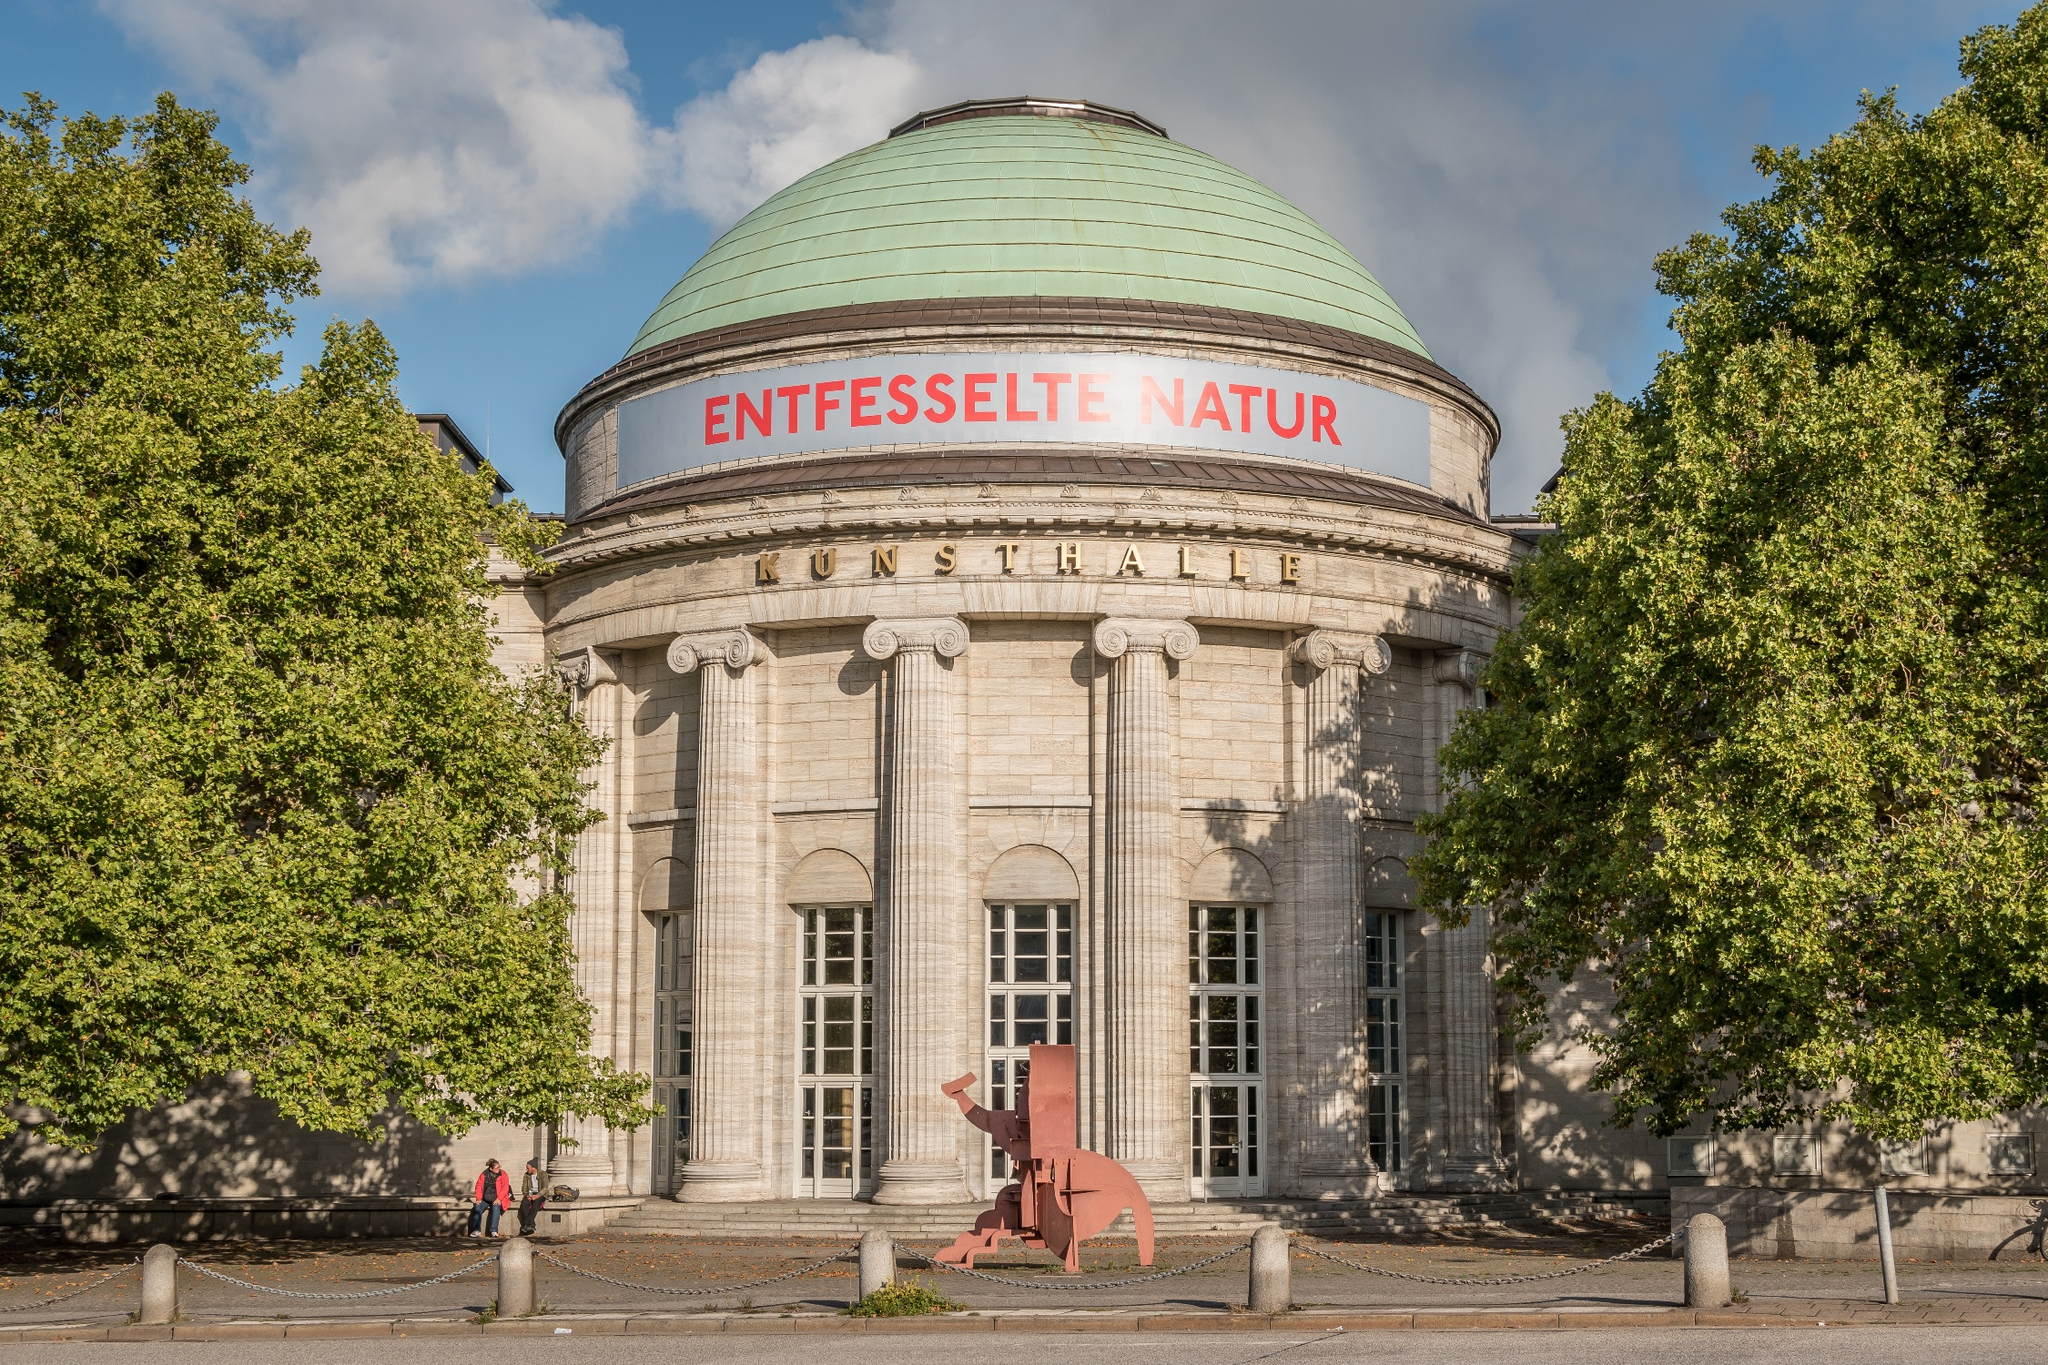What is this photo about'? The image captures the magnificent Kunsthalle Hamburg, a renowned art museum located in Hamburg, Germany. This architectural gem is an example of neoclassical design, characterized by a grand dome with a green patina and supported by elegant white columns. Nestled among vibrant trees, the museum offers a harmonious blend of nature and urban splendor. A striking red sculpture adorns the entrance, immediately catching the eye of visitors. The words 'ENTFESSELTE NATUR' (Unleashed Nature) and 'KUNSTHALLE' are prominently displayed above the entrance, inviting art enthusiasts to delve into the natural and artistic treasures housed within. The image is taken from a street-level perspective, giving a welcoming view that beckons onlookers to explore the cultural richness within the museum. 